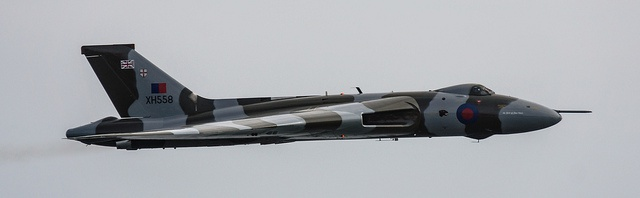Describe the objects in this image and their specific colors. I can see a airplane in lightgray, black, gray, darkgray, and darkblue tones in this image. 